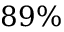<formula> <loc_0><loc_0><loc_500><loc_500>8 9 \%</formula> 